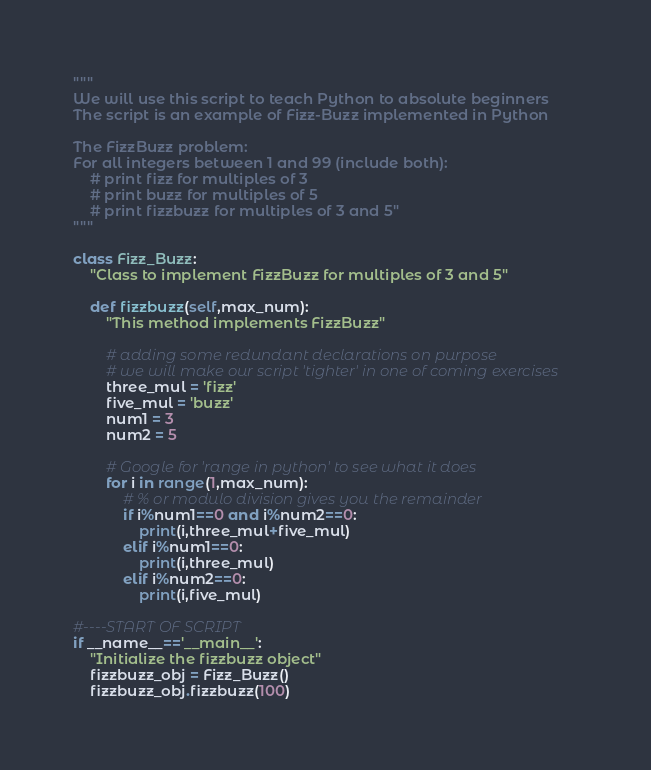<code> <loc_0><loc_0><loc_500><loc_500><_Python_>"""
We will use this script to teach Python to absolute beginners
The script is an example of Fizz-Buzz implemented in Python

The FizzBuzz problem: 
For all integers between 1 and 99 (include both):
    # print fizz for multiples of 3
    # print buzz for multiples of 5 
    # print fizzbuzz for multiples of 3 and 5"
"""

class Fizz_Buzz:
    "Class to implement FizzBuzz for multiples of 3 and 5"
    
    def fizzbuzz(self,max_num):
        "This method implements FizzBuzz"
        
        # adding some redundant declarations on purpose
        # we will make our script 'tighter' in one of coming exercises
        three_mul = 'fizz'
        five_mul = 'buzz'
        num1 = 3
        num2 = 5 

        # Google for 'range in python' to see what it does
        for i in range(1,max_num):
            # % or modulo division gives you the remainder 
            if i%num1==0 and i%num2==0:
                print(i,three_mul+five_mul)
            elif i%num1==0:
                print(i,three_mul)
            elif i%num2==0:
                print(i,five_mul)

#----START OF SCRIPT
if __name__=='__main__':
    "Initialize the fizzbuzz object"
    fizzbuzz_obj = Fizz_Buzz()
    fizzbuzz_obj.fizzbuzz(100)

</code> 